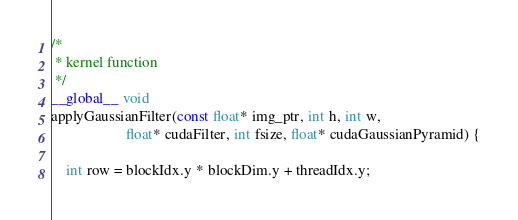<code> <loc_0><loc_0><loc_500><loc_500><_Cuda_>/*
 * kernel function
 */
__global__ void
applyGaussianFilter(const float* img_ptr, int h, int w, 
                    float* cudaFilter, int fsize, float* cudaGaussianPyramid) {

    int row = blockIdx.y * blockDim.y + threadIdx.y;</code> 